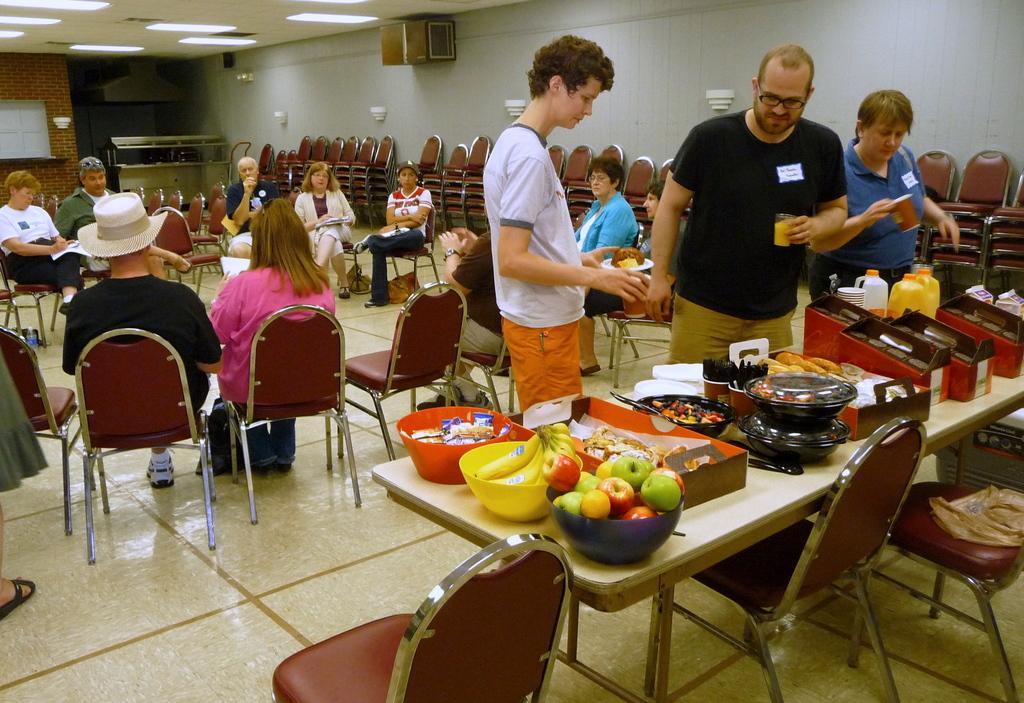Can you describe this image briefly? This picture is clicked inside. On the right there is a wooden table on the top of which we can see the fruits, bowls containing food items, bottles, boxes and many other objects and we can see the red color chairs placed on the ground and we can see the group of persons holding some objects and standing on the ground and we can see the group of persons sitting on the chairs. In the background there is a wall, roof, ceiling lights, window and many other objects. 